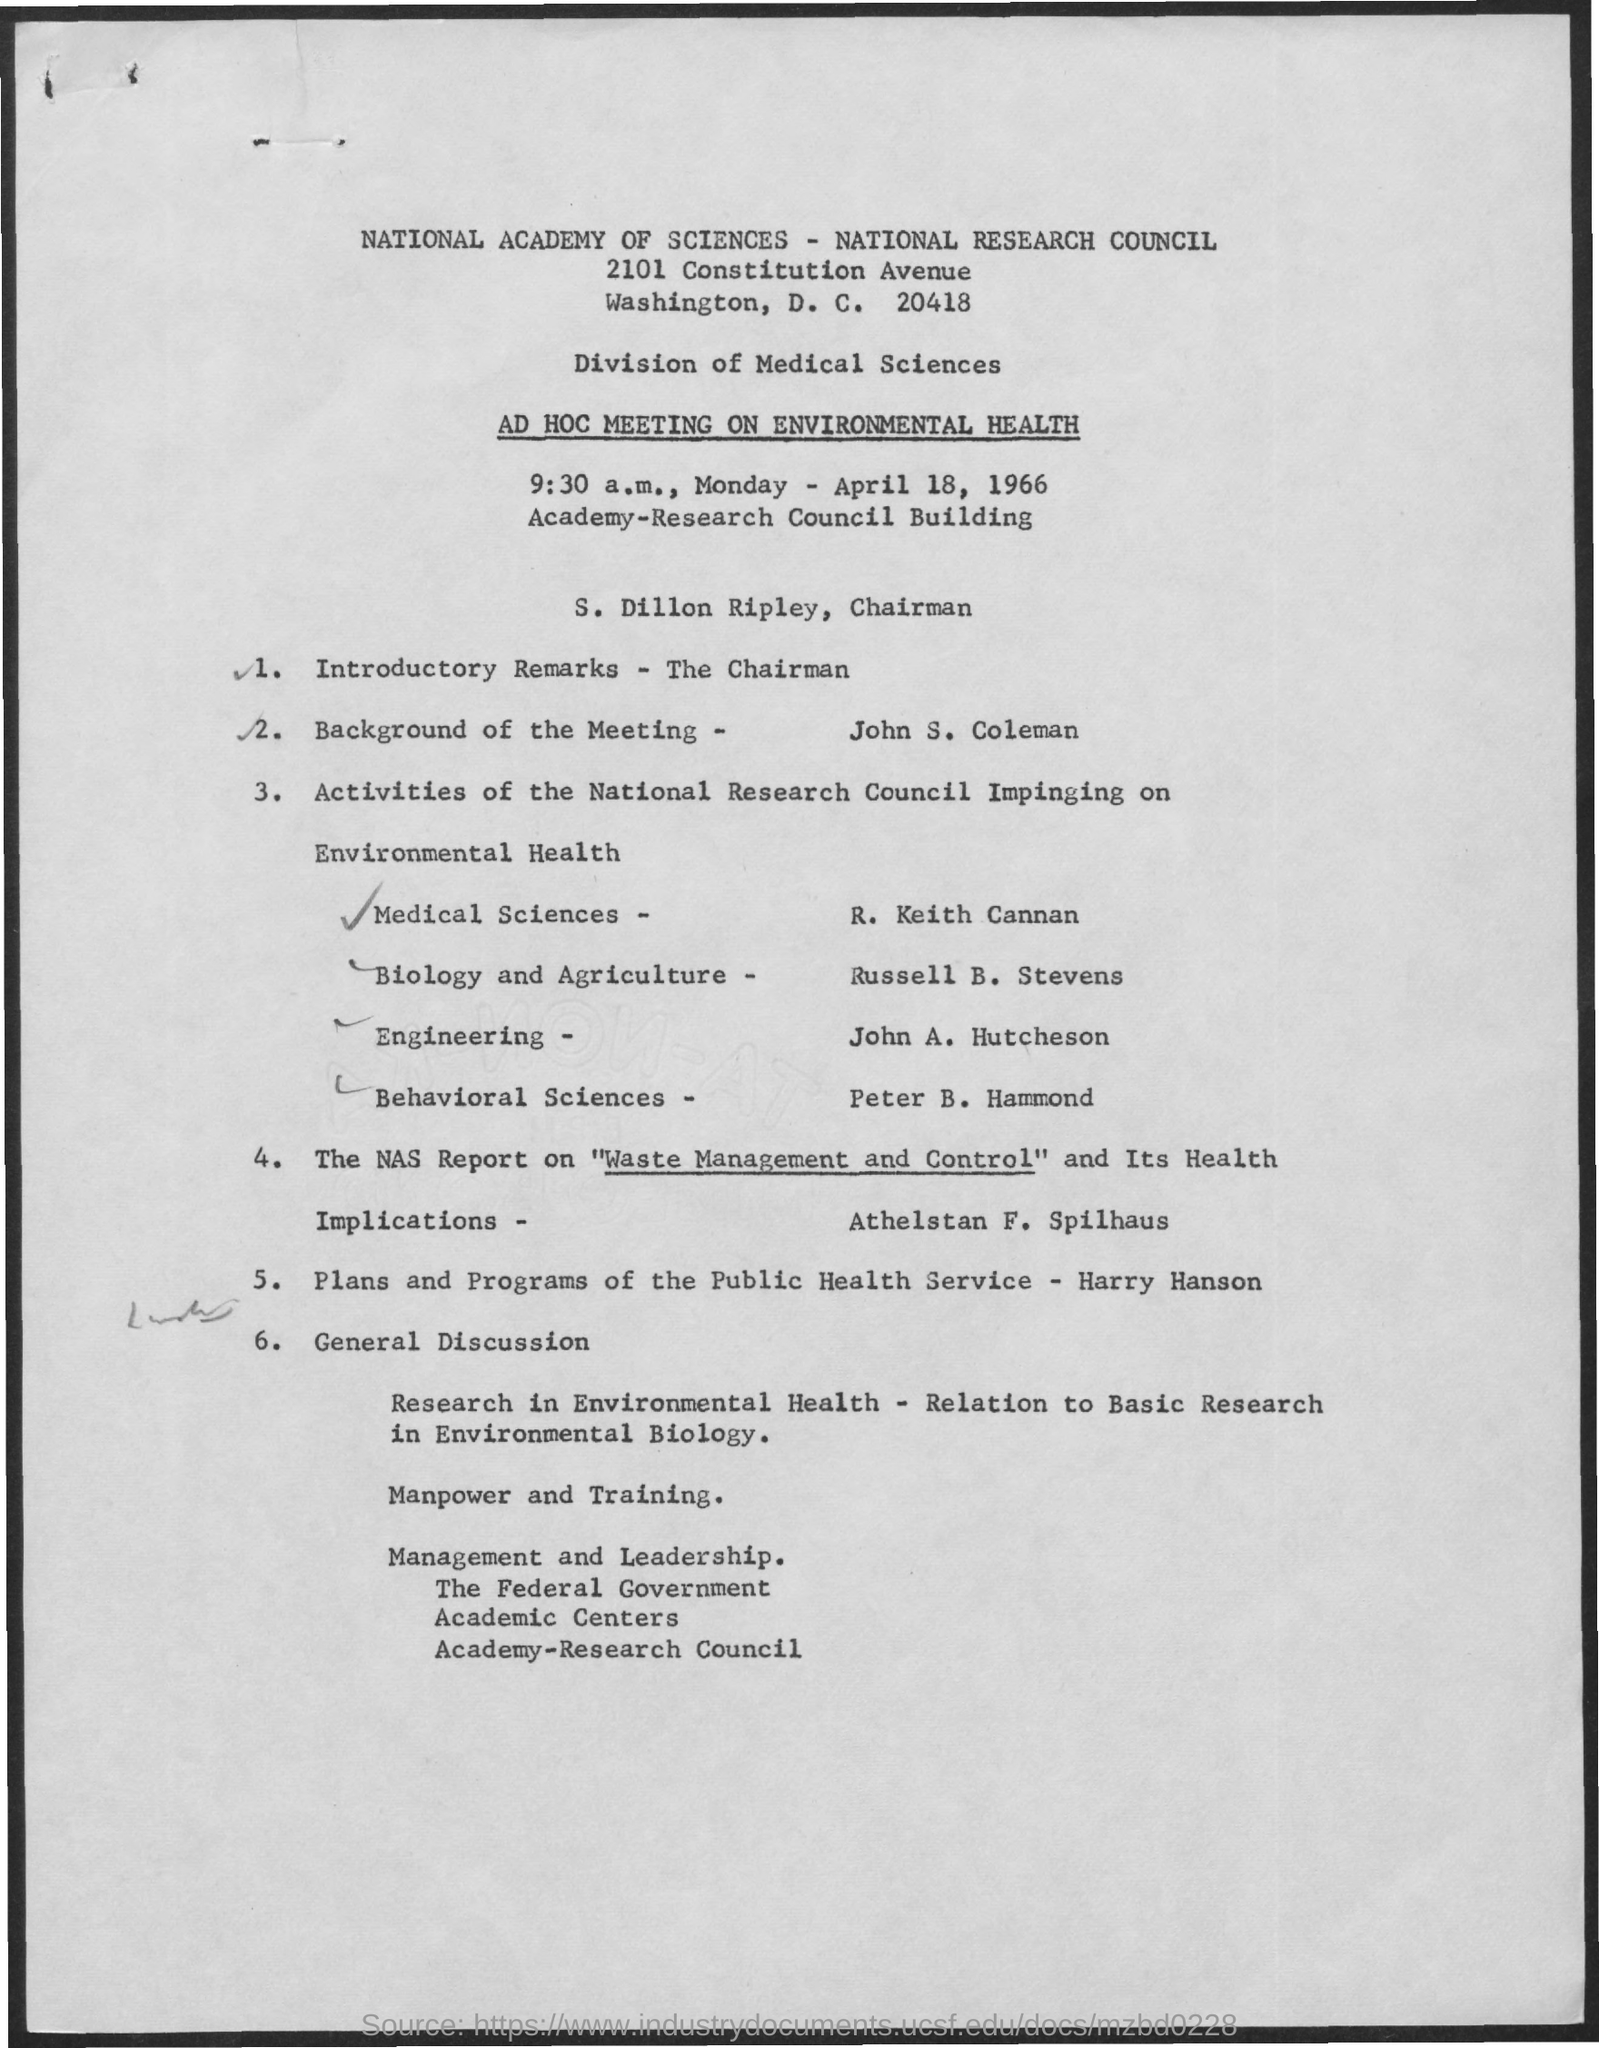Who is the Chairman?
Provide a short and direct response. S. dillon ripley. 